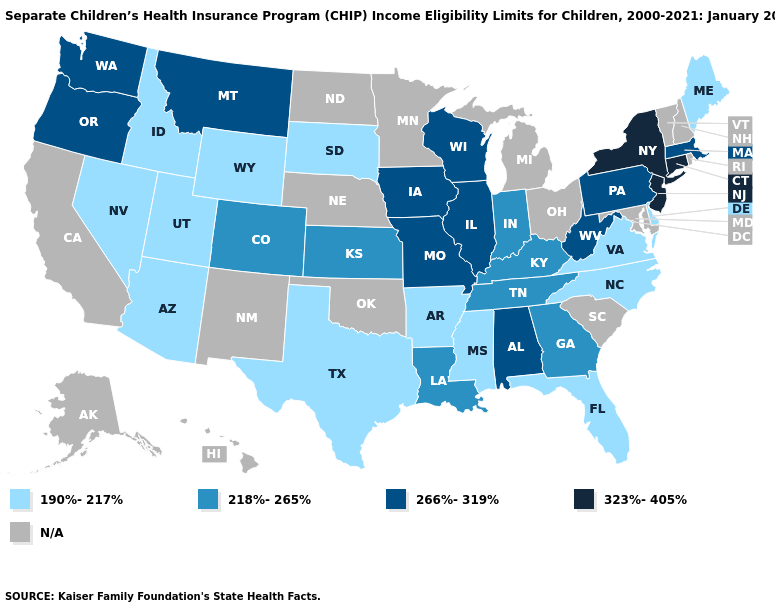What is the highest value in the South ?
Give a very brief answer. 266%-319%. What is the highest value in states that border Oklahoma?
Short answer required. 266%-319%. Name the states that have a value in the range 190%-217%?
Be succinct. Arizona, Arkansas, Delaware, Florida, Idaho, Maine, Mississippi, Nevada, North Carolina, South Dakota, Texas, Utah, Virginia, Wyoming. What is the lowest value in the MidWest?
Short answer required. 190%-217%. How many symbols are there in the legend?
Keep it brief. 5. Which states have the lowest value in the Northeast?
Be succinct. Maine. Name the states that have a value in the range 190%-217%?
Keep it brief. Arizona, Arkansas, Delaware, Florida, Idaho, Maine, Mississippi, Nevada, North Carolina, South Dakota, Texas, Utah, Virginia, Wyoming. Does the map have missing data?
Give a very brief answer. Yes. Does the map have missing data?
Write a very short answer. Yes. Name the states that have a value in the range N/A?
Give a very brief answer. Alaska, California, Hawaii, Maryland, Michigan, Minnesota, Nebraska, New Hampshire, New Mexico, North Dakota, Ohio, Oklahoma, Rhode Island, South Carolina, Vermont. What is the value of Alabama?
Concise answer only. 266%-319%. Does Massachusetts have the highest value in the USA?
Short answer required. No. Which states hav the highest value in the Northeast?
Quick response, please. Connecticut, New Jersey, New York. 